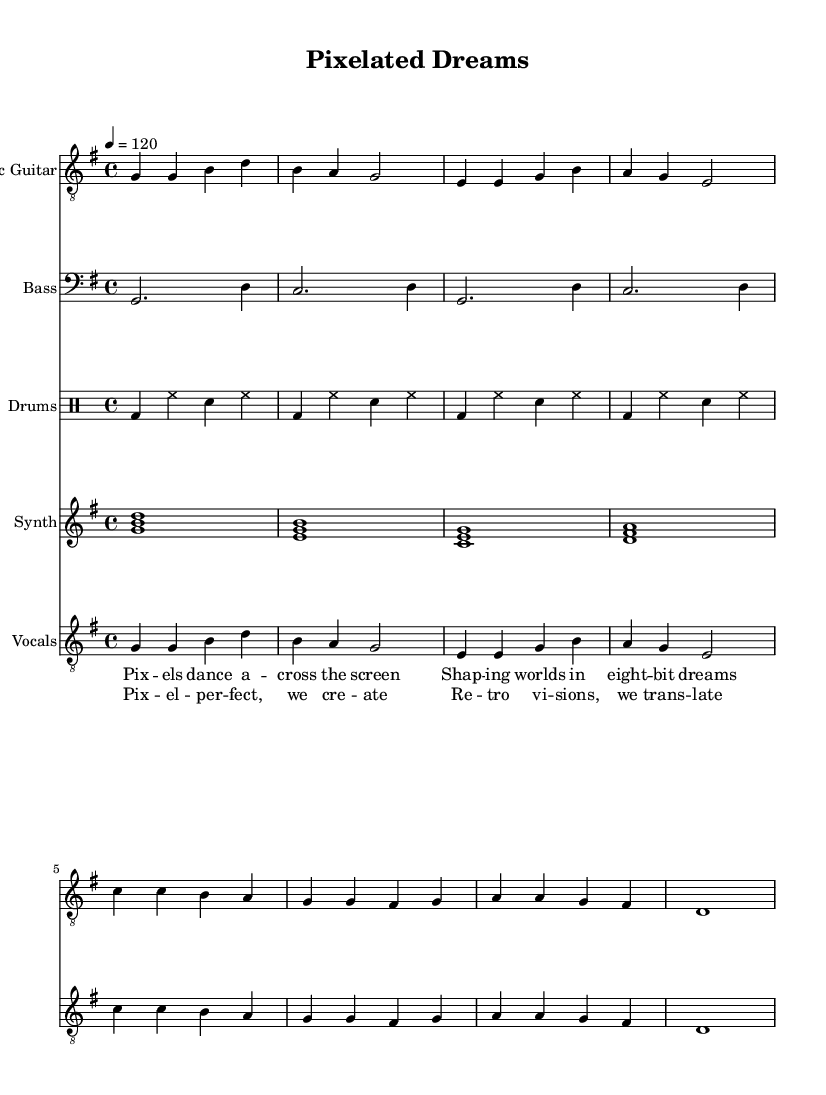What is the key signature of this music? The key signature is G major, which has one sharp (F#). This can be determined from the key signature indicator at the beginning of the piece.
Answer: G major What is the time signature of this music? The time signature is 4/4, indicated at the beginning of the score. This means there are four beats in each measure, and the quarter note gets one beat.
Answer: 4/4 What is the tempo marking for this piece? The tempo marking is 120 beats per minute, indicated at the beginning of the score with "4 = 120." This tells the performer how fast to play the music.
Answer: 120 How many instruments are featured in this score? There are four instruments featured in the score: Electric Guitar, Bass, Drums, and Synth. This can be ascertained by counting the distinct instrument staves listed in the score.
Answer: Four Which lyrics are associated with the chorus? The lyrics associated with the chorus are "Pixel-perfect, we create, Retro visions, we translate." This can be found in the "chorus" section of the lyrics underneath the staff.
Answer: Pixel-perfect, we create, Retro visions, we translate What musical genre does this piece belong to? This piece belongs to the Indie Rock genre, which is indicated by the style and thematic content of the lyrics, focusing on digital art and pixel-perfect creations.
Answer: Indie Rock 